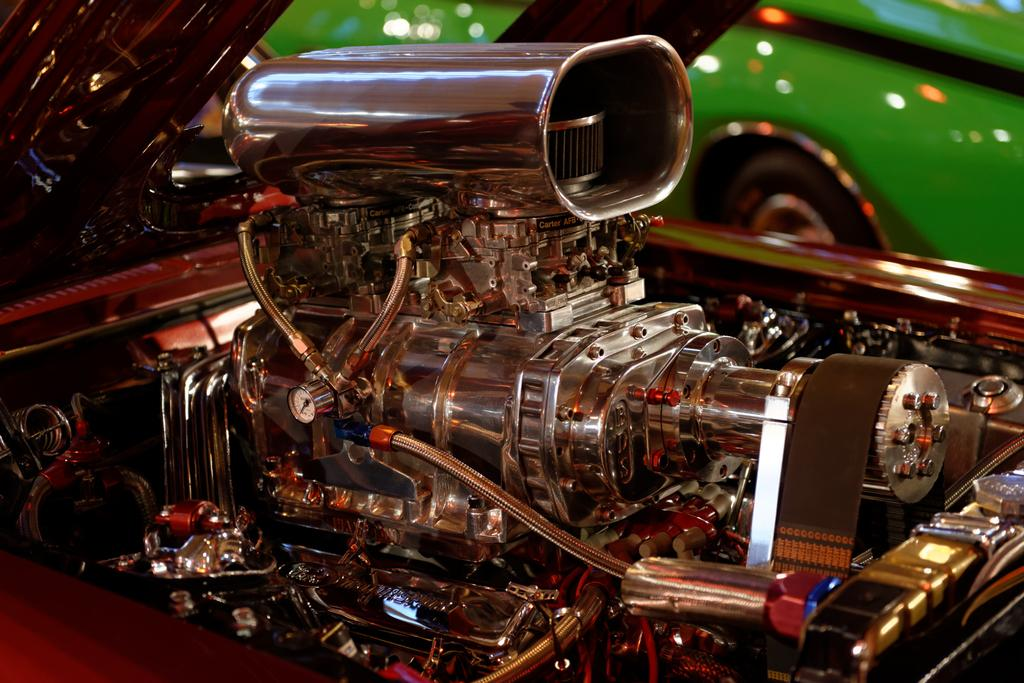What type of objects are featured in the image? The image contains engine parts of a vehicle and other parts. Can you describe the setting of the image? There is a car in the background of the image. What type of account is being discussed in the image? There is no account being discussed in the image; it features engine parts of a vehicle and other parts. Is there a coat visible in the image? No, there is no coat present in the image. 